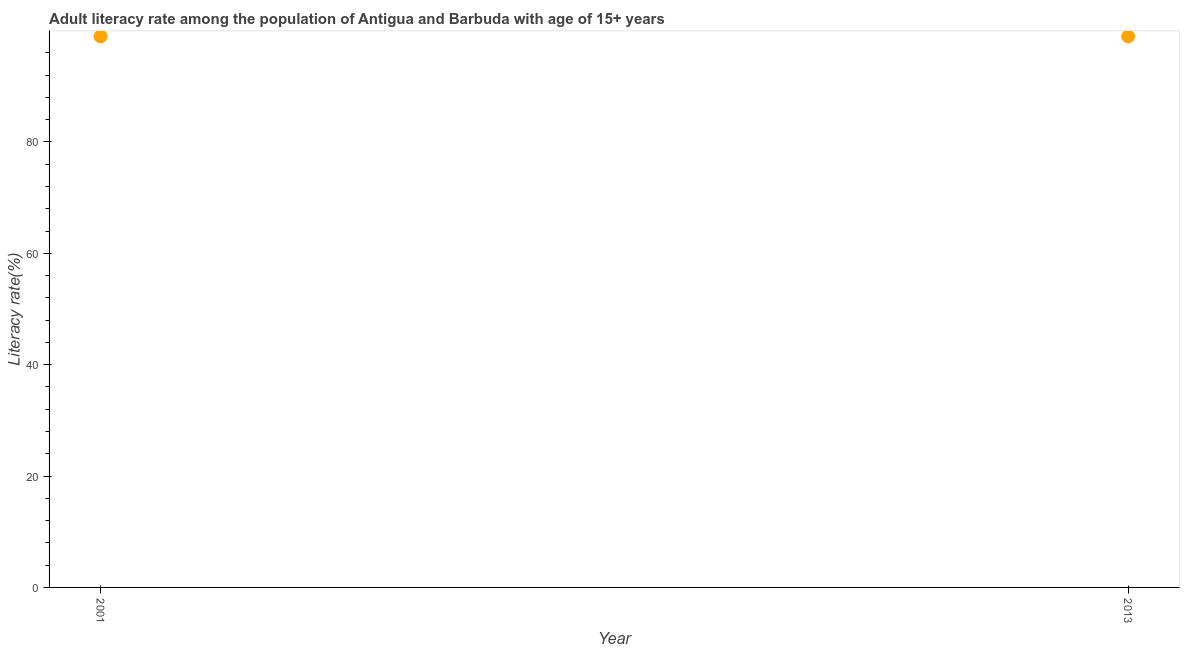What is the adult literacy rate in 2013?
Your answer should be compact. 98.95. Across all years, what is the maximum adult literacy rate?
Give a very brief answer. 98.95. Across all years, what is the minimum adult literacy rate?
Your answer should be very brief. 98.95. In which year was the adult literacy rate minimum?
Keep it short and to the point. 2001. What is the sum of the adult literacy rate?
Offer a very short reply. 197.9. What is the average adult literacy rate per year?
Your answer should be compact. 98.95. What is the median adult literacy rate?
Your answer should be compact. 98.95. Do a majority of the years between 2013 and 2001 (inclusive) have adult literacy rate greater than 64 %?
Keep it short and to the point. No. In how many years, is the adult literacy rate greater than the average adult literacy rate taken over all years?
Provide a succinct answer. 0. What is the title of the graph?
Keep it short and to the point. Adult literacy rate among the population of Antigua and Barbuda with age of 15+ years. What is the label or title of the Y-axis?
Your response must be concise. Literacy rate(%). What is the Literacy rate(%) in 2001?
Offer a terse response. 98.95. What is the Literacy rate(%) in 2013?
Offer a very short reply. 98.95. What is the difference between the Literacy rate(%) in 2001 and 2013?
Offer a very short reply. 0. 